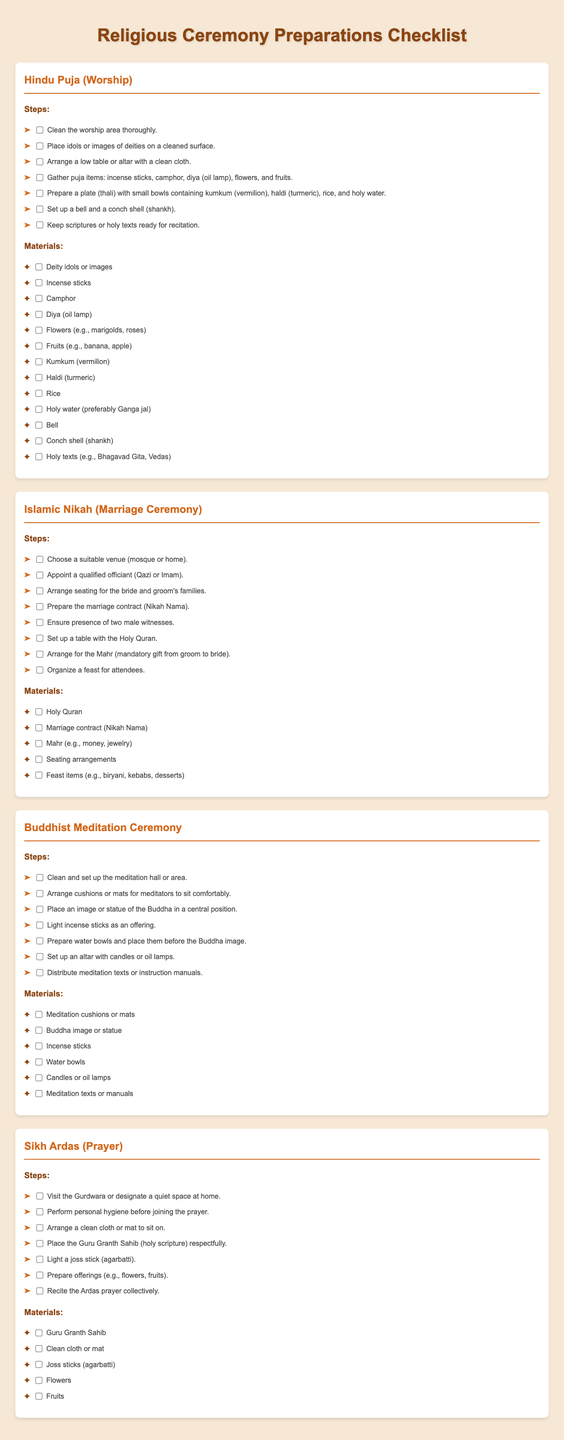What are the materials needed for Hindu Puja? The materials needed for Hindu Puja are listed in the document, including items like deity idols, incense sticks, and fruits.
Answer: Deity idols, incense sticks, camphor, diya, flowers, fruits, kumkum, haldi, rice, holy water, bell, conch shell, holy texts How many steps are there for the Islamic Nikah? The number of steps for the Islamic Nikah is provided in the document.
Answer: Eight What is Mahr in an Islamic Nikah? Mahr is explained in the context of its necessity in the Nikah procedure as a mandatory gift from groom to bride.
Answer: Mandatory gift Which holy text is placed at the Buddhist Meditation Ceremony? The holy text mentioned at the Buddhist Meditation Ceremony is indicated in the listed materials.
Answer: Meditation texts What is the venue for a Sikh Ardas? The document specifies that the Gurdwara or a quiet space at home can be the venue for the Sikh Ardas.
Answer: Gurdwara What provides the lighting in a Buddhist Meditation Ceremony? The source of lighting for the Buddhist Meditation Ceremony is noted, which includes candles or oil lamps.
Answer: Candles or oil lamps What needs to be prepared before the Islamic Nikah? The document outlines that the marriage contract (Nikah Nama) must be prepared before the Islamic Nikah.
Answer: Marriage contract What are the main offerings in a Sikh Ardas? The main offerings for the Sikh Ardas Prayer are detailed in the list of materials.
Answer: Flowers, fruits 